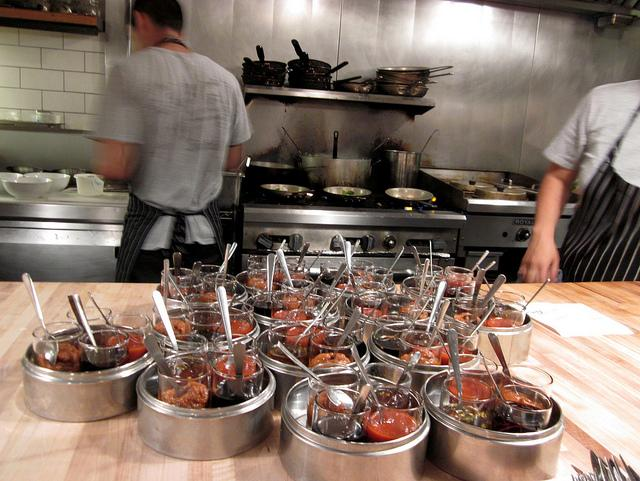Inside silver round large cans what is seen here in profusion?

Choices:
A) meats
B) condiments
C) main dish
D) side dish condiments 